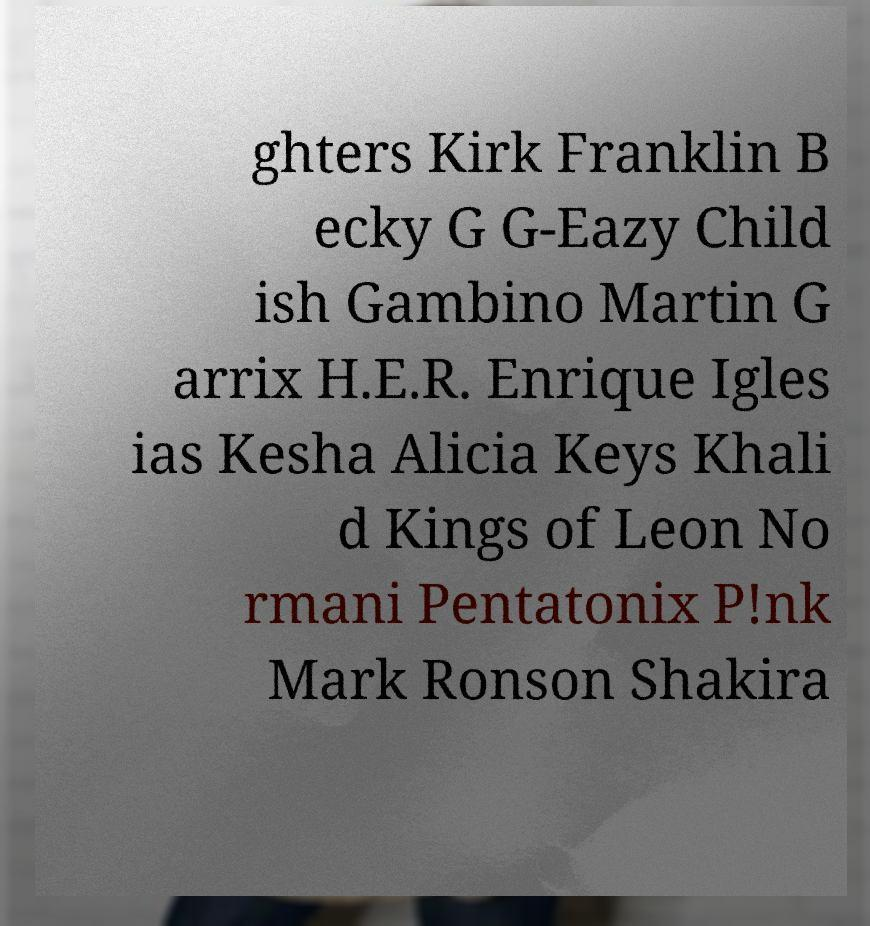Please identify and transcribe the text found in this image. ghters Kirk Franklin B ecky G G-Eazy Child ish Gambino Martin G arrix H.E.R. Enrique Igles ias Kesha Alicia Keys Khali d Kings of Leon No rmani Pentatonix P!nk Mark Ronson Shakira 